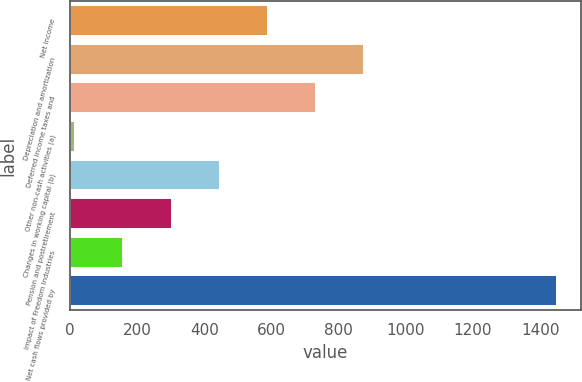Convert chart to OTSL. <chart><loc_0><loc_0><loc_500><loc_500><bar_chart><fcel>Net income<fcel>Depreciation and amortization<fcel>Deferred income taxes and<fcel>Other non-cash activities (a)<fcel>Changes in working capital (b)<fcel>Pension and postretirement<fcel>Impact of Freedom Industries<fcel>Net cash flows provided by<nl><fcel>589.2<fcel>875.8<fcel>732.5<fcel>16<fcel>445.9<fcel>302.6<fcel>159.3<fcel>1449<nl></chart> 